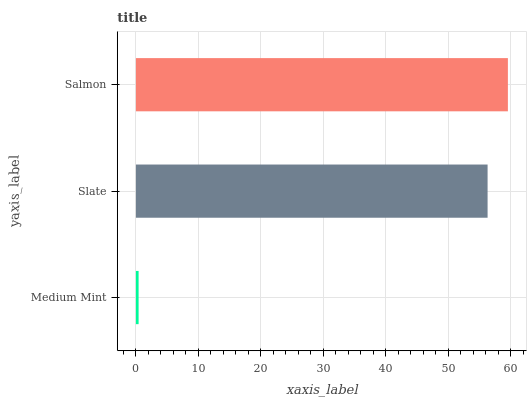Is Medium Mint the minimum?
Answer yes or no. Yes. Is Salmon the maximum?
Answer yes or no. Yes. Is Slate the minimum?
Answer yes or no. No. Is Slate the maximum?
Answer yes or no. No. Is Slate greater than Medium Mint?
Answer yes or no. Yes. Is Medium Mint less than Slate?
Answer yes or no. Yes. Is Medium Mint greater than Slate?
Answer yes or no. No. Is Slate less than Medium Mint?
Answer yes or no. No. Is Slate the high median?
Answer yes or no. Yes. Is Slate the low median?
Answer yes or no. Yes. Is Medium Mint the high median?
Answer yes or no. No. Is Medium Mint the low median?
Answer yes or no. No. 